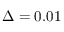Convert formula to latex. <formula><loc_0><loc_0><loc_500><loc_500>\Delta = 0 . 0 1</formula> 